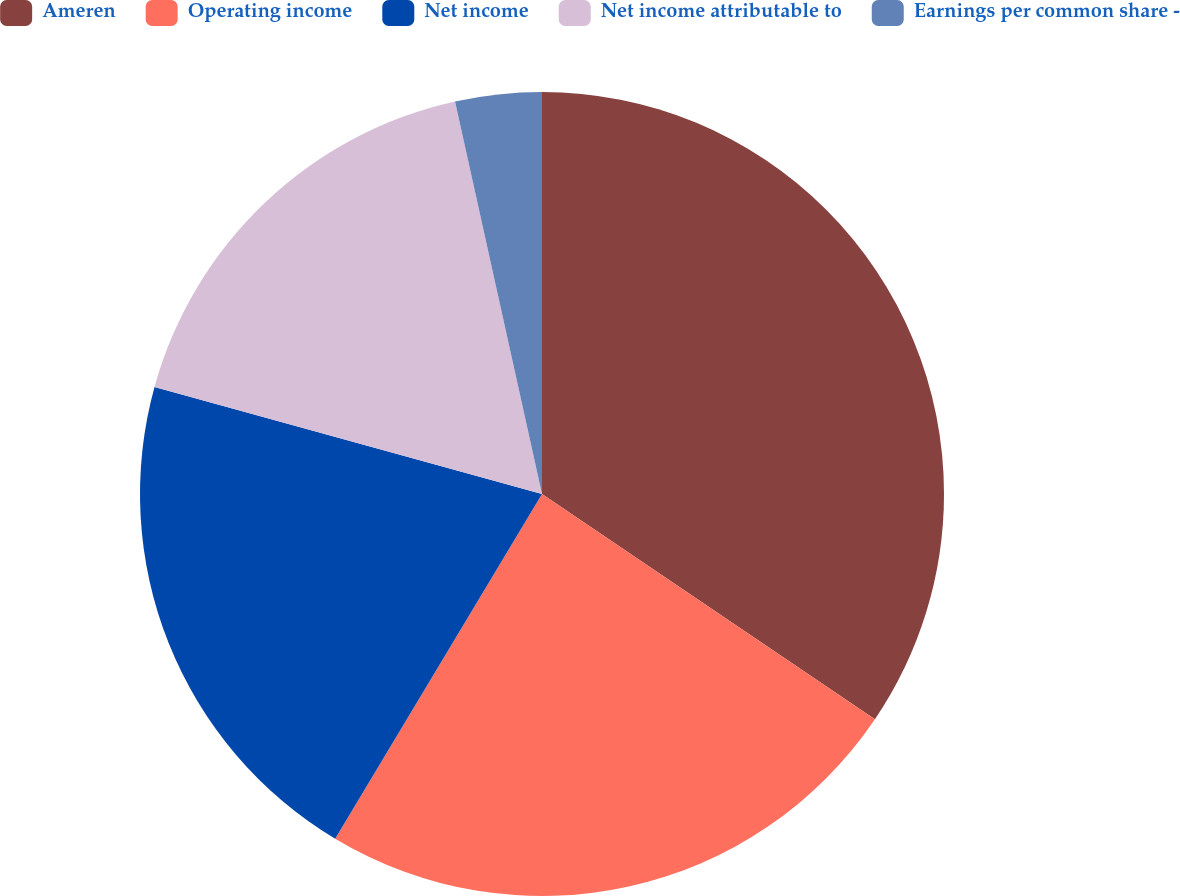<chart> <loc_0><loc_0><loc_500><loc_500><pie_chart><fcel>Ameren<fcel>Operating income<fcel>Net income<fcel>Net income attributable to<fcel>Earnings per common share -<nl><fcel>34.47%<fcel>24.13%<fcel>20.69%<fcel>17.24%<fcel>3.47%<nl></chart> 